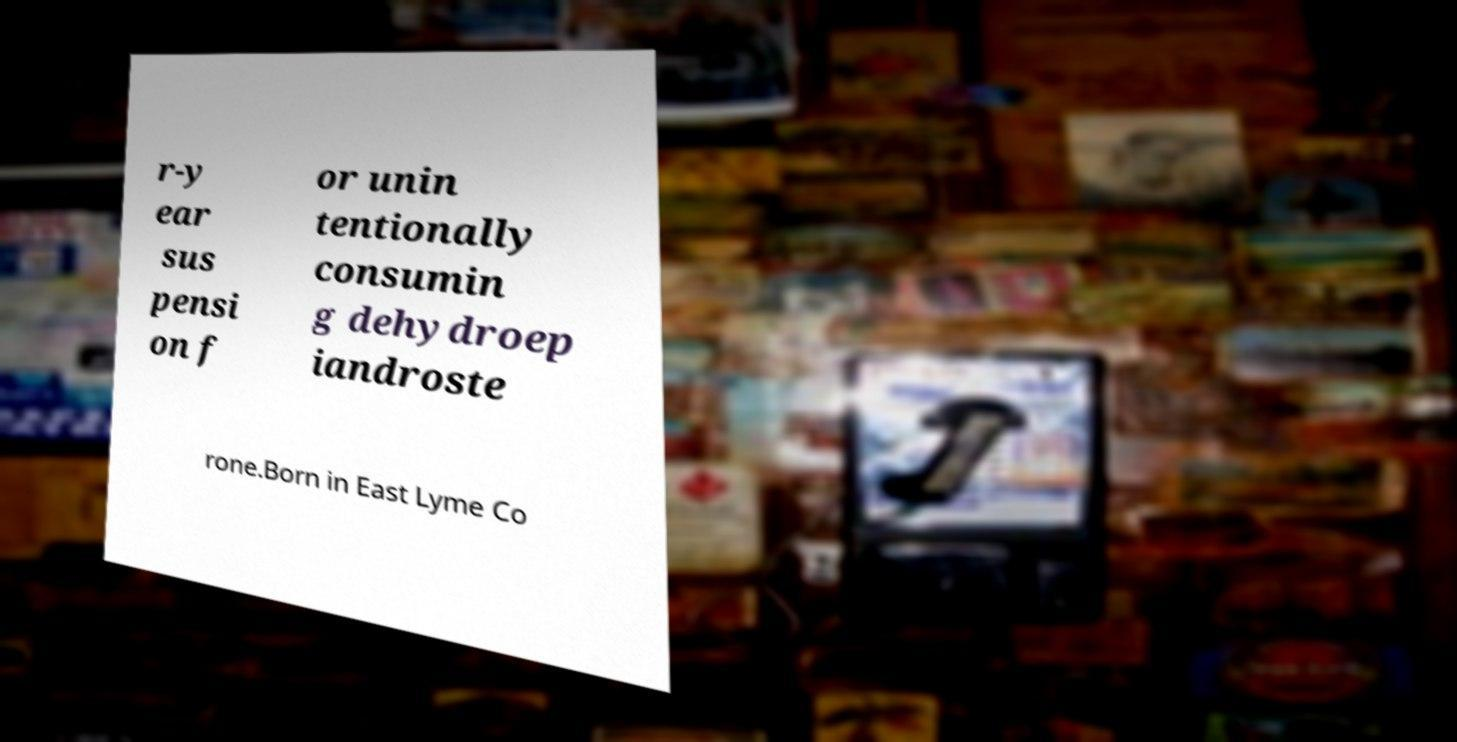Can you accurately transcribe the text from the provided image for me? r-y ear sus pensi on f or unin tentionally consumin g dehydroep iandroste rone.Born in East Lyme Co 